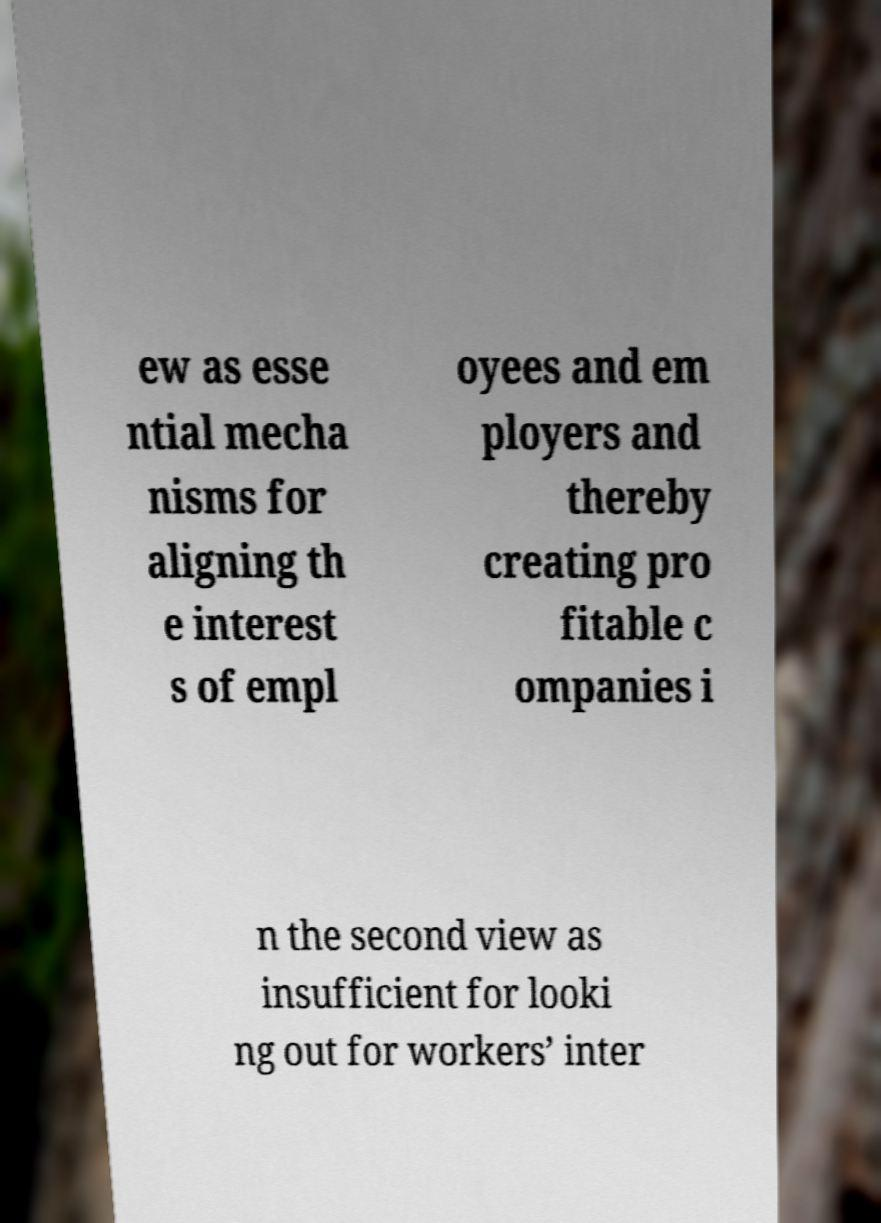Can you accurately transcribe the text from the provided image for me? ew as esse ntial mecha nisms for aligning th e interest s of empl oyees and em ployers and thereby creating pro fitable c ompanies i n the second view as insufficient for looki ng out for workers’ inter 